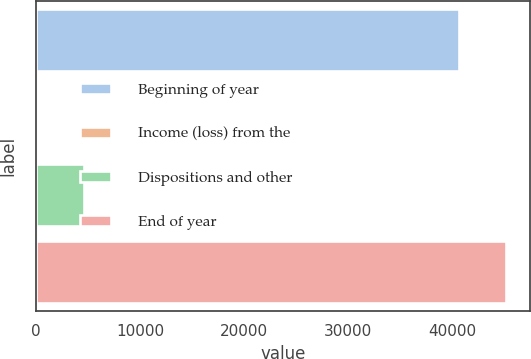<chart> <loc_0><loc_0><loc_500><loc_500><bar_chart><fcel>Beginning of year<fcel>Income (loss) from the<fcel>Dispositions and other<fcel>End of year<nl><fcel>40697<fcel>88<fcel>4566.8<fcel>45175.8<nl></chart> 